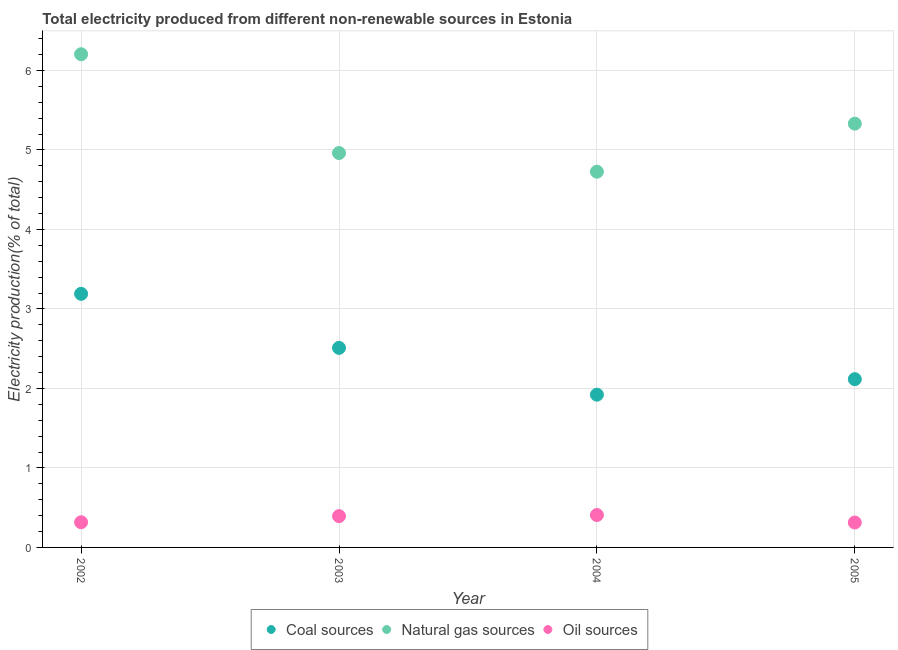How many different coloured dotlines are there?
Your response must be concise. 3. What is the percentage of electricity produced by natural gas in 2003?
Your answer should be very brief. 4.96. Across all years, what is the maximum percentage of electricity produced by coal?
Keep it short and to the point. 3.19. Across all years, what is the minimum percentage of electricity produced by oil sources?
Your answer should be very brief. 0.31. In which year was the percentage of electricity produced by coal maximum?
Your answer should be compact. 2002. In which year was the percentage of electricity produced by coal minimum?
Your answer should be very brief. 2004. What is the total percentage of electricity produced by coal in the graph?
Offer a terse response. 9.74. What is the difference between the percentage of electricity produced by oil sources in 2003 and that in 2005?
Make the answer very short. 0.08. What is the difference between the percentage of electricity produced by natural gas in 2002 and the percentage of electricity produced by coal in 2004?
Offer a terse response. 4.28. What is the average percentage of electricity produced by coal per year?
Offer a terse response. 2.43. In the year 2002, what is the difference between the percentage of electricity produced by oil sources and percentage of electricity produced by natural gas?
Your answer should be compact. -5.89. What is the ratio of the percentage of electricity produced by oil sources in 2002 to that in 2003?
Give a very brief answer. 0.8. Is the percentage of electricity produced by coal in 2002 less than that in 2005?
Give a very brief answer. No. Is the difference between the percentage of electricity produced by natural gas in 2003 and 2004 greater than the difference between the percentage of electricity produced by oil sources in 2003 and 2004?
Your response must be concise. Yes. What is the difference between the highest and the second highest percentage of electricity produced by oil sources?
Ensure brevity in your answer.  0.01. What is the difference between the highest and the lowest percentage of electricity produced by natural gas?
Offer a terse response. 1.48. Is it the case that in every year, the sum of the percentage of electricity produced by coal and percentage of electricity produced by natural gas is greater than the percentage of electricity produced by oil sources?
Provide a succinct answer. Yes. Is the percentage of electricity produced by natural gas strictly less than the percentage of electricity produced by coal over the years?
Ensure brevity in your answer.  No. How many dotlines are there?
Offer a terse response. 3. What is the difference between two consecutive major ticks on the Y-axis?
Ensure brevity in your answer.  1. Where does the legend appear in the graph?
Provide a short and direct response. Bottom center. How are the legend labels stacked?
Provide a succinct answer. Horizontal. What is the title of the graph?
Your response must be concise. Total electricity produced from different non-renewable sources in Estonia. Does "Labor Tax" appear as one of the legend labels in the graph?
Your response must be concise. No. What is the Electricity production(% of total) in Coal sources in 2002?
Keep it short and to the point. 3.19. What is the Electricity production(% of total) of Natural gas sources in 2002?
Your response must be concise. 6.2. What is the Electricity production(% of total) of Oil sources in 2002?
Offer a terse response. 0.32. What is the Electricity production(% of total) in Coal sources in 2003?
Keep it short and to the point. 2.51. What is the Electricity production(% of total) in Natural gas sources in 2003?
Provide a short and direct response. 4.96. What is the Electricity production(% of total) of Oil sources in 2003?
Offer a terse response. 0.39. What is the Electricity production(% of total) of Coal sources in 2004?
Ensure brevity in your answer.  1.92. What is the Electricity production(% of total) in Natural gas sources in 2004?
Ensure brevity in your answer.  4.73. What is the Electricity production(% of total) in Oil sources in 2004?
Provide a succinct answer. 0.41. What is the Electricity production(% of total) of Coal sources in 2005?
Keep it short and to the point. 2.12. What is the Electricity production(% of total) of Natural gas sources in 2005?
Offer a terse response. 5.33. What is the Electricity production(% of total) in Oil sources in 2005?
Ensure brevity in your answer.  0.31. Across all years, what is the maximum Electricity production(% of total) of Coal sources?
Give a very brief answer. 3.19. Across all years, what is the maximum Electricity production(% of total) of Natural gas sources?
Provide a succinct answer. 6.2. Across all years, what is the maximum Electricity production(% of total) in Oil sources?
Make the answer very short. 0.41. Across all years, what is the minimum Electricity production(% of total) in Coal sources?
Keep it short and to the point. 1.92. Across all years, what is the minimum Electricity production(% of total) in Natural gas sources?
Provide a short and direct response. 4.73. Across all years, what is the minimum Electricity production(% of total) in Oil sources?
Keep it short and to the point. 0.31. What is the total Electricity production(% of total) of Coal sources in the graph?
Keep it short and to the point. 9.74. What is the total Electricity production(% of total) in Natural gas sources in the graph?
Your answer should be compact. 21.22. What is the total Electricity production(% of total) in Oil sources in the graph?
Give a very brief answer. 1.43. What is the difference between the Electricity production(% of total) of Coal sources in 2002 and that in 2003?
Your answer should be compact. 0.68. What is the difference between the Electricity production(% of total) of Natural gas sources in 2002 and that in 2003?
Ensure brevity in your answer.  1.24. What is the difference between the Electricity production(% of total) of Oil sources in 2002 and that in 2003?
Offer a terse response. -0.08. What is the difference between the Electricity production(% of total) in Coal sources in 2002 and that in 2004?
Your answer should be compact. 1.27. What is the difference between the Electricity production(% of total) in Natural gas sources in 2002 and that in 2004?
Keep it short and to the point. 1.48. What is the difference between the Electricity production(% of total) in Oil sources in 2002 and that in 2004?
Your answer should be compact. -0.09. What is the difference between the Electricity production(% of total) in Coal sources in 2002 and that in 2005?
Provide a succinct answer. 1.07. What is the difference between the Electricity production(% of total) in Natural gas sources in 2002 and that in 2005?
Ensure brevity in your answer.  0.87. What is the difference between the Electricity production(% of total) in Oil sources in 2002 and that in 2005?
Keep it short and to the point. 0. What is the difference between the Electricity production(% of total) of Coal sources in 2003 and that in 2004?
Keep it short and to the point. 0.59. What is the difference between the Electricity production(% of total) of Natural gas sources in 2003 and that in 2004?
Provide a short and direct response. 0.23. What is the difference between the Electricity production(% of total) of Oil sources in 2003 and that in 2004?
Give a very brief answer. -0.01. What is the difference between the Electricity production(% of total) of Coal sources in 2003 and that in 2005?
Give a very brief answer. 0.39. What is the difference between the Electricity production(% of total) in Natural gas sources in 2003 and that in 2005?
Give a very brief answer. -0.37. What is the difference between the Electricity production(% of total) in Oil sources in 2003 and that in 2005?
Your response must be concise. 0.08. What is the difference between the Electricity production(% of total) in Coal sources in 2004 and that in 2005?
Give a very brief answer. -0.2. What is the difference between the Electricity production(% of total) in Natural gas sources in 2004 and that in 2005?
Your answer should be very brief. -0.6. What is the difference between the Electricity production(% of total) of Oil sources in 2004 and that in 2005?
Your response must be concise. 0.09. What is the difference between the Electricity production(% of total) in Coal sources in 2002 and the Electricity production(% of total) in Natural gas sources in 2003?
Your response must be concise. -1.77. What is the difference between the Electricity production(% of total) in Coal sources in 2002 and the Electricity production(% of total) in Oil sources in 2003?
Give a very brief answer. 2.8. What is the difference between the Electricity production(% of total) of Natural gas sources in 2002 and the Electricity production(% of total) of Oil sources in 2003?
Offer a terse response. 5.81. What is the difference between the Electricity production(% of total) in Coal sources in 2002 and the Electricity production(% of total) in Natural gas sources in 2004?
Offer a very short reply. -1.54. What is the difference between the Electricity production(% of total) in Coal sources in 2002 and the Electricity production(% of total) in Oil sources in 2004?
Provide a short and direct response. 2.78. What is the difference between the Electricity production(% of total) in Natural gas sources in 2002 and the Electricity production(% of total) in Oil sources in 2004?
Make the answer very short. 5.8. What is the difference between the Electricity production(% of total) of Coal sources in 2002 and the Electricity production(% of total) of Natural gas sources in 2005?
Your answer should be compact. -2.14. What is the difference between the Electricity production(% of total) in Coal sources in 2002 and the Electricity production(% of total) in Oil sources in 2005?
Provide a short and direct response. 2.88. What is the difference between the Electricity production(% of total) of Natural gas sources in 2002 and the Electricity production(% of total) of Oil sources in 2005?
Provide a succinct answer. 5.89. What is the difference between the Electricity production(% of total) of Coal sources in 2003 and the Electricity production(% of total) of Natural gas sources in 2004?
Ensure brevity in your answer.  -2.22. What is the difference between the Electricity production(% of total) of Coal sources in 2003 and the Electricity production(% of total) of Oil sources in 2004?
Ensure brevity in your answer.  2.1. What is the difference between the Electricity production(% of total) of Natural gas sources in 2003 and the Electricity production(% of total) of Oil sources in 2004?
Ensure brevity in your answer.  4.55. What is the difference between the Electricity production(% of total) in Coal sources in 2003 and the Electricity production(% of total) in Natural gas sources in 2005?
Give a very brief answer. -2.82. What is the difference between the Electricity production(% of total) of Coal sources in 2003 and the Electricity production(% of total) of Oil sources in 2005?
Offer a terse response. 2.2. What is the difference between the Electricity production(% of total) in Natural gas sources in 2003 and the Electricity production(% of total) in Oil sources in 2005?
Keep it short and to the point. 4.65. What is the difference between the Electricity production(% of total) in Coal sources in 2004 and the Electricity production(% of total) in Natural gas sources in 2005?
Offer a terse response. -3.41. What is the difference between the Electricity production(% of total) in Coal sources in 2004 and the Electricity production(% of total) in Oil sources in 2005?
Your answer should be very brief. 1.61. What is the difference between the Electricity production(% of total) of Natural gas sources in 2004 and the Electricity production(% of total) of Oil sources in 2005?
Offer a terse response. 4.41. What is the average Electricity production(% of total) of Coal sources per year?
Your response must be concise. 2.43. What is the average Electricity production(% of total) of Natural gas sources per year?
Your answer should be very brief. 5.31. What is the average Electricity production(% of total) of Oil sources per year?
Make the answer very short. 0.36. In the year 2002, what is the difference between the Electricity production(% of total) in Coal sources and Electricity production(% of total) in Natural gas sources?
Your answer should be very brief. -3.01. In the year 2002, what is the difference between the Electricity production(% of total) in Coal sources and Electricity production(% of total) in Oil sources?
Give a very brief answer. 2.87. In the year 2002, what is the difference between the Electricity production(% of total) in Natural gas sources and Electricity production(% of total) in Oil sources?
Make the answer very short. 5.89. In the year 2003, what is the difference between the Electricity production(% of total) in Coal sources and Electricity production(% of total) in Natural gas sources?
Your answer should be compact. -2.45. In the year 2003, what is the difference between the Electricity production(% of total) of Coal sources and Electricity production(% of total) of Oil sources?
Offer a terse response. 2.12. In the year 2003, what is the difference between the Electricity production(% of total) in Natural gas sources and Electricity production(% of total) in Oil sources?
Ensure brevity in your answer.  4.57. In the year 2004, what is the difference between the Electricity production(% of total) in Coal sources and Electricity production(% of total) in Natural gas sources?
Give a very brief answer. -2.8. In the year 2004, what is the difference between the Electricity production(% of total) of Coal sources and Electricity production(% of total) of Oil sources?
Offer a terse response. 1.51. In the year 2004, what is the difference between the Electricity production(% of total) in Natural gas sources and Electricity production(% of total) in Oil sources?
Make the answer very short. 4.32. In the year 2005, what is the difference between the Electricity production(% of total) in Coal sources and Electricity production(% of total) in Natural gas sources?
Make the answer very short. -3.21. In the year 2005, what is the difference between the Electricity production(% of total) in Coal sources and Electricity production(% of total) in Oil sources?
Offer a terse response. 1.8. In the year 2005, what is the difference between the Electricity production(% of total) in Natural gas sources and Electricity production(% of total) in Oil sources?
Provide a short and direct response. 5.02. What is the ratio of the Electricity production(% of total) in Coal sources in 2002 to that in 2003?
Offer a terse response. 1.27. What is the ratio of the Electricity production(% of total) in Natural gas sources in 2002 to that in 2003?
Ensure brevity in your answer.  1.25. What is the ratio of the Electricity production(% of total) in Oil sources in 2002 to that in 2003?
Provide a succinct answer. 0.8. What is the ratio of the Electricity production(% of total) in Coal sources in 2002 to that in 2004?
Your answer should be very brief. 1.66. What is the ratio of the Electricity production(% of total) in Natural gas sources in 2002 to that in 2004?
Keep it short and to the point. 1.31. What is the ratio of the Electricity production(% of total) of Oil sources in 2002 to that in 2004?
Provide a succinct answer. 0.78. What is the ratio of the Electricity production(% of total) of Coal sources in 2002 to that in 2005?
Provide a short and direct response. 1.51. What is the ratio of the Electricity production(% of total) in Natural gas sources in 2002 to that in 2005?
Offer a very short reply. 1.16. What is the ratio of the Electricity production(% of total) of Oil sources in 2002 to that in 2005?
Offer a terse response. 1.01. What is the ratio of the Electricity production(% of total) in Coal sources in 2003 to that in 2004?
Your response must be concise. 1.31. What is the ratio of the Electricity production(% of total) of Natural gas sources in 2003 to that in 2004?
Your answer should be very brief. 1.05. What is the ratio of the Electricity production(% of total) in Coal sources in 2003 to that in 2005?
Your answer should be compact. 1.19. What is the ratio of the Electricity production(% of total) of Natural gas sources in 2003 to that in 2005?
Your response must be concise. 0.93. What is the ratio of the Electricity production(% of total) in Oil sources in 2003 to that in 2005?
Your response must be concise. 1.26. What is the ratio of the Electricity production(% of total) in Coal sources in 2004 to that in 2005?
Make the answer very short. 0.91. What is the ratio of the Electricity production(% of total) of Natural gas sources in 2004 to that in 2005?
Provide a short and direct response. 0.89. What is the ratio of the Electricity production(% of total) in Oil sources in 2004 to that in 2005?
Give a very brief answer. 1.3. What is the difference between the highest and the second highest Electricity production(% of total) in Coal sources?
Provide a short and direct response. 0.68. What is the difference between the highest and the second highest Electricity production(% of total) in Natural gas sources?
Keep it short and to the point. 0.87. What is the difference between the highest and the second highest Electricity production(% of total) of Oil sources?
Keep it short and to the point. 0.01. What is the difference between the highest and the lowest Electricity production(% of total) in Coal sources?
Give a very brief answer. 1.27. What is the difference between the highest and the lowest Electricity production(% of total) in Natural gas sources?
Your response must be concise. 1.48. What is the difference between the highest and the lowest Electricity production(% of total) of Oil sources?
Make the answer very short. 0.09. 